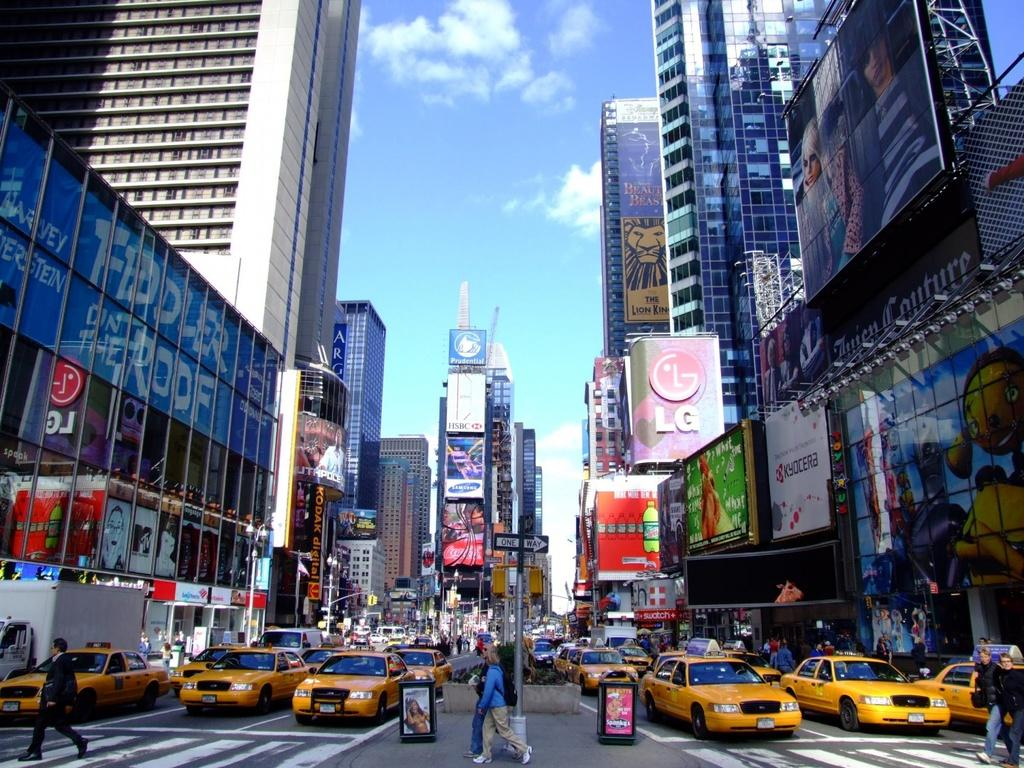Provide a one-sentence caption for the provided image. a city street with LG above some of the buildings. 